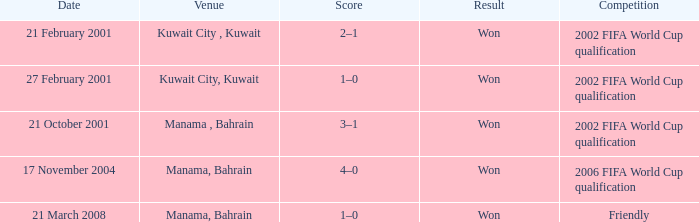On which date was the 2006 FIFA World Cup Qualification in Manama, Bahrain? 17 November 2004. Write the full table. {'header': ['Date', 'Venue', 'Score', 'Result', 'Competition'], 'rows': [['21 February 2001', 'Kuwait City , Kuwait', '2–1', 'Won', '2002 FIFA World Cup qualification'], ['27 February 2001', 'Kuwait City, Kuwait', '1–0', 'Won', '2002 FIFA World Cup qualification'], ['21 October 2001', 'Manama , Bahrain', '3–1', 'Won', '2002 FIFA World Cup qualification'], ['17 November 2004', 'Manama, Bahrain', '4–0', 'Won', '2006 FIFA World Cup qualification'], ['21 March 2008', 'Manama, Bahrain', '1–0', 'Won', 'Friendly']]} 